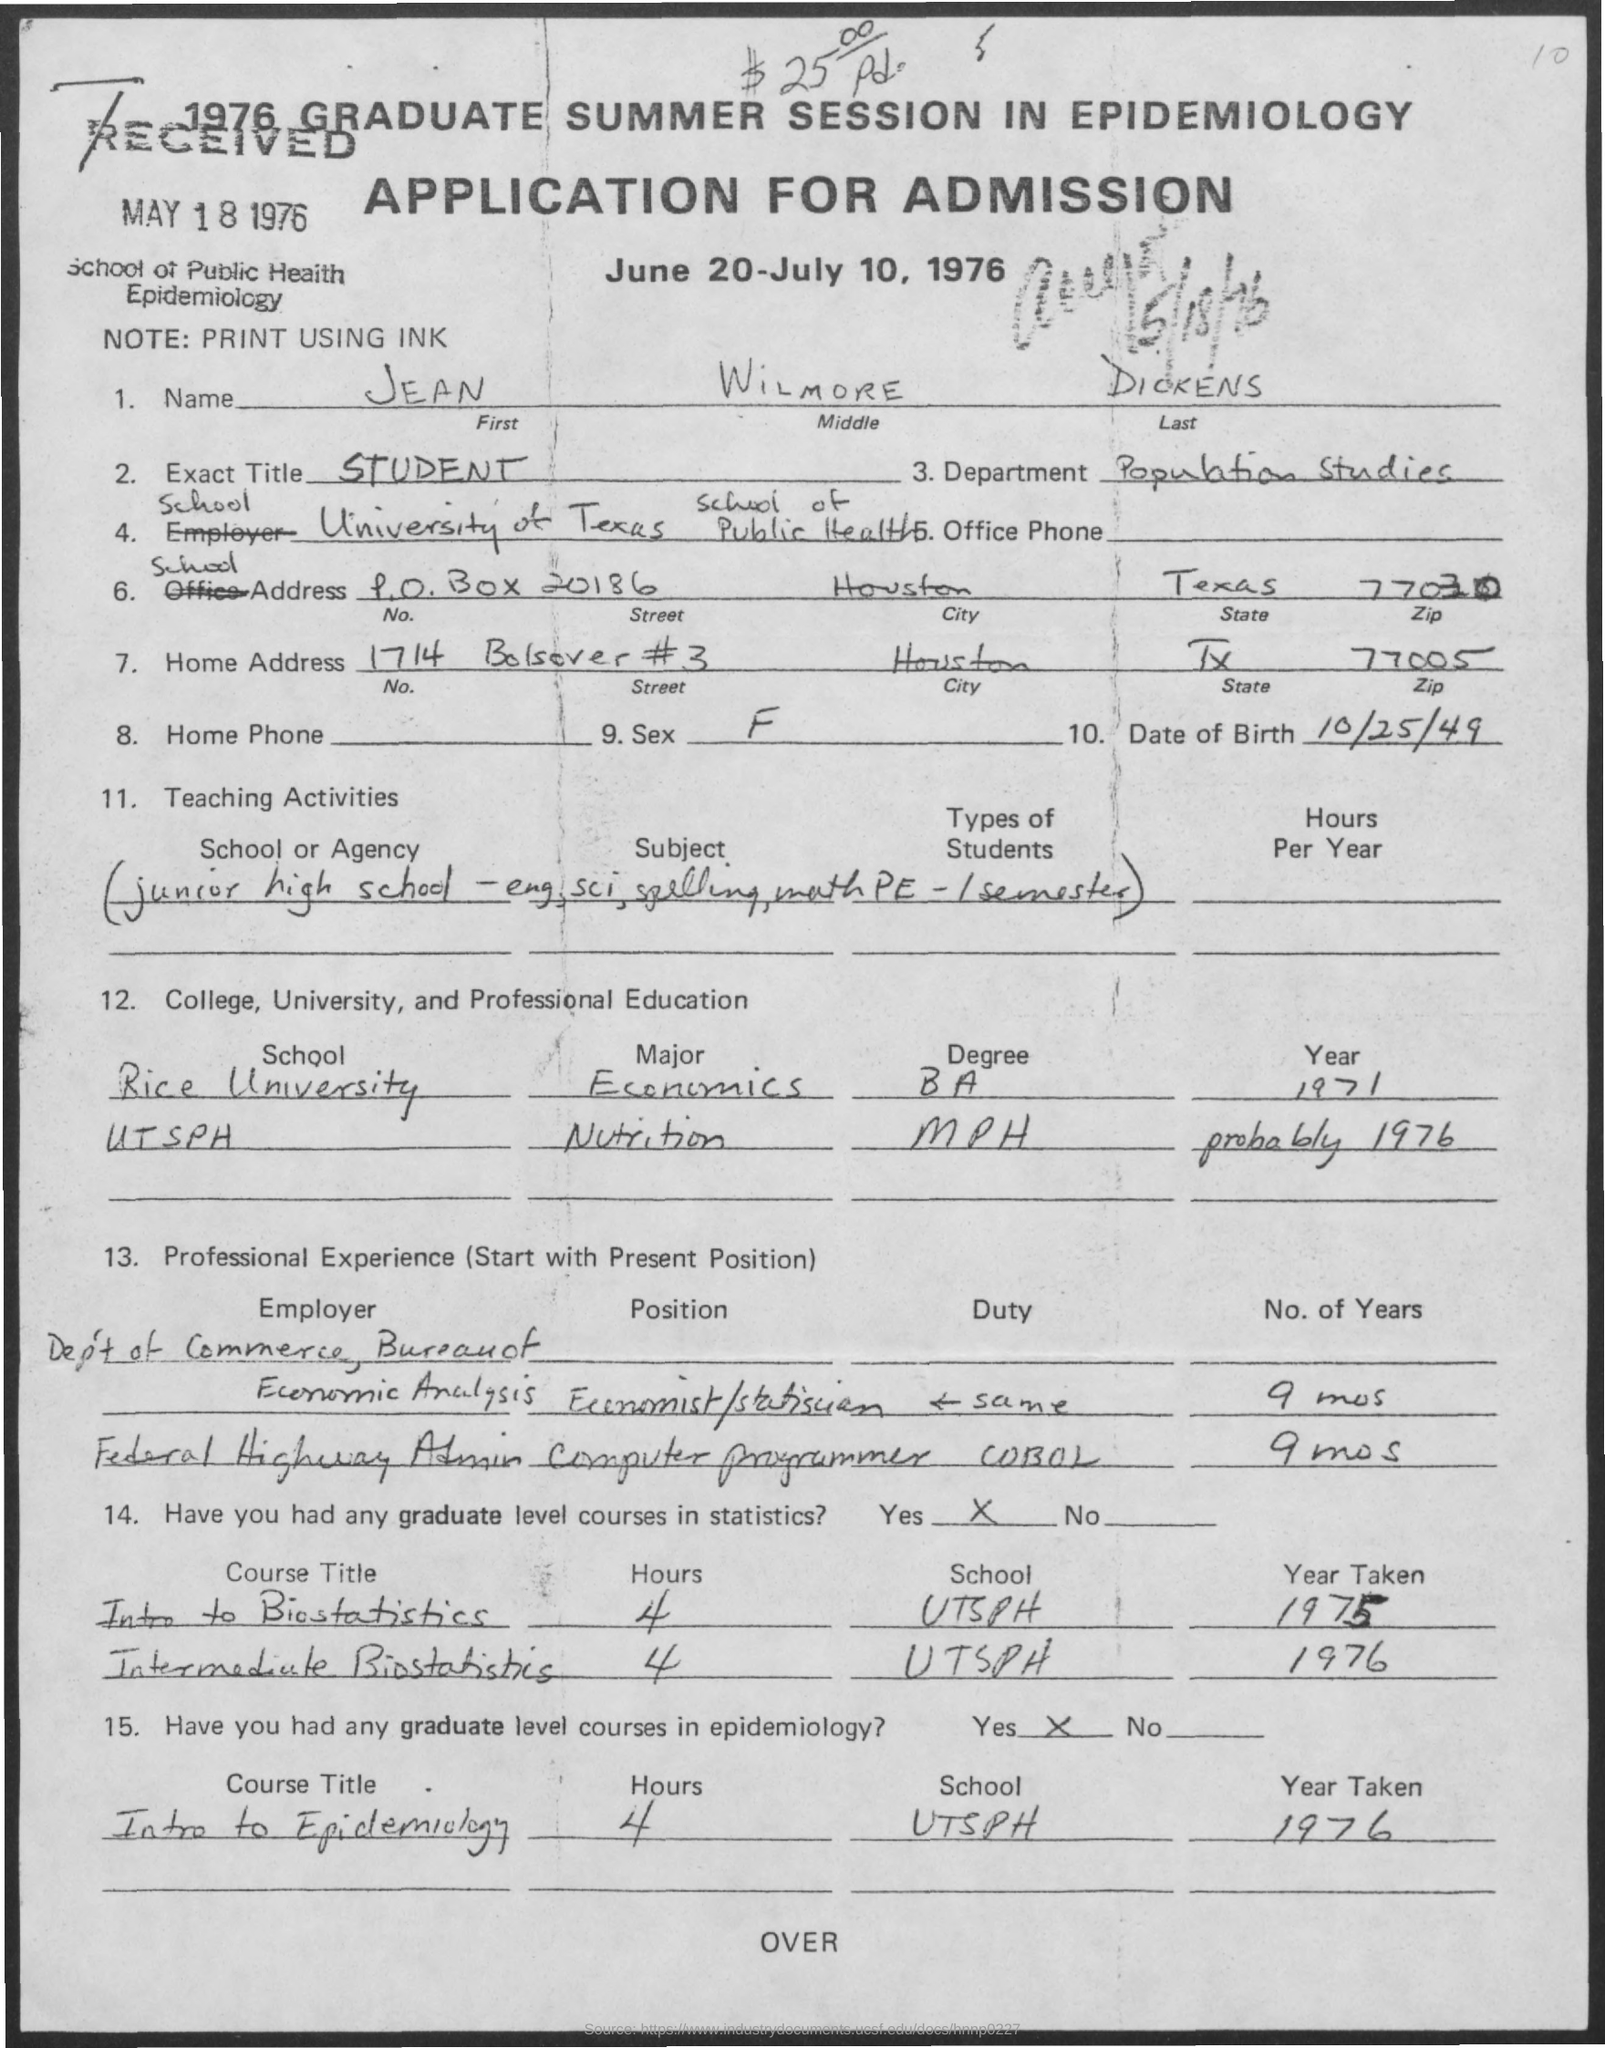On which date the application was received ?
Offer a very short reply. May 18 , 1976. What is the note mentioned in the given application ?
Make the answer very short. Print using ink. What is the first name mentioned in the given application ?
Make the answer very short. JEAN. What is the middle name as mentioned in the given application ?
Keep it short and to the point. Wilmore. What is the name of the department mentioned in the given application ?
Provide a short and direct response. Population studies. What is the exact title mentioned in the given application ?
Offer a terse response. Student. What is the date of birth mentioned in the given application ?
Your answer should be compact. 10/25/49. What is the sex mentioned in the given application ?
Provide a short and direct response. F. What is the zip number for home address  mentioned in the given application ?
Give a very brief answer. 77005. 